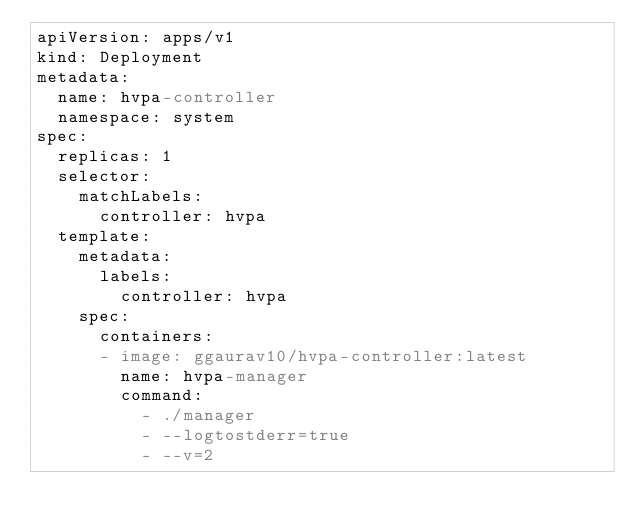Convert code to text. <code><loc_0><loc_0><loc_500><loc_500><_YAML_>apiVersion: apps/v1
kind: Deployment
metadata:
  name: hvpa-controller
  namespace: system
spec:
  replicas: 1
  selector:
    matchLabels:
      controller: hvpa
  template:
    metadata:
      labels:
        controller: hvpa
    spec:
      containers:
      - image: ggaurav10/hvpa-controller:latest
        name: hvpa-manager
        command:
          - ./manager
          - --logtostderr=true 
          - --v=2

</code> 